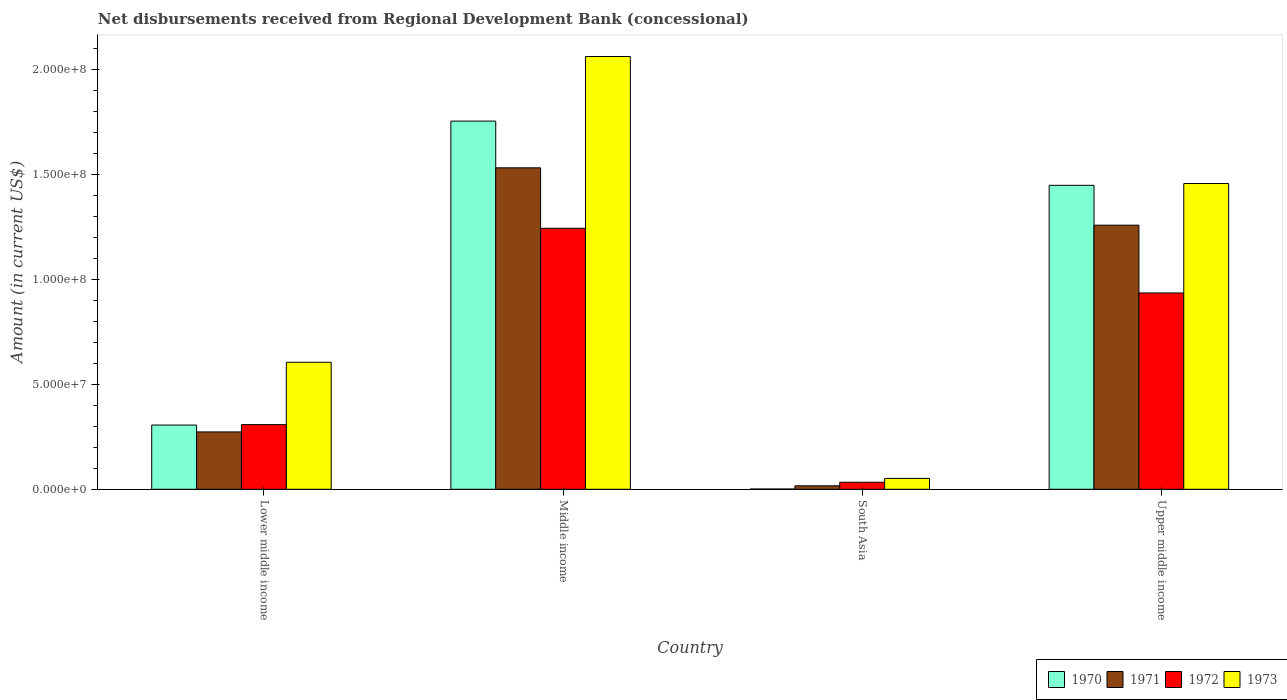How many different coloured bars are there?
Offer a terse response. 4. Are the number of bars per tick equal to the number of legend labels?
Offer a very short reply. Yes. Are the number of bars on each tick of the X-axis equal?
Offer a terse response. Yes. What is the label of the 1st group of bars from the left?
Give a very brief answer. Lower middle income. In how many cases, is the number of bars for a given country not equal to the number of legend labels?
Keep it short and to the point. 0. What is the amount of disbursements received from Regional Development Bank in 1973 in Middle income?
Ensure brevity in your answer.  2.06e+08. Across all countries, what is the maximum amount of disbursements received from Regional Development Bank in 1971?
Provide a succinct answer. 1.53e+08. Across all countries, what is the minimum amount of disbursements received from Regional Development Bank in 1973?
Provide a succinct answer. 5.18e+06. In which country was the amount of disbursements received from Regional Development Bank in 1971 maximum?
Give a very brief answer. Middle income. What is the total amount of disbursements received from Regional Development Bank in 1972 in the graph?
Offer a terse response. 2.52e+08. What is the difference between the amount of disbursements received from Regional Development Bank in 1973 in Lower middle income and that in South Asia?
Offer a very short reply. 5.54e+07. What is the difference between the amount of disbursements received from Regional Development Bank in 1970 in South Asia and the amount of disbursements received from Regional Development Bank in 1971 in Lower middle income?
Ensure brevity in your answer.  -2.72e+07. What is the average amount of disbursements received from Regional Development Bank in 1971 per country?
Offer a terse response. 7.70e+07. What is the difference between the amount of disbursements received from Regional Development Bank of/in 1971 and amount of disbursements received from Regional Development Bank of/in 1972 in Lower middle income?
Your response must be concise. -3.47e+06. In how many countries, is the amount of disbursements received from Regional Development Bank in 1970 greater than 120000000 US$?
Offer a very short reply. 2. What is the ratio of the amount of disbursements received from Regional Development Bank in 1973 in Lower middle income to that in South Asia?
Ensure brevity in your answer.  11.68. Is the amount of disbursements received from Regional Development Bank in 1971 in Lower middle income less than that in South Asia?
Ensure brevity in your answer.  No. Is the difference between the amount of disbursements received from Regional Development Bank in 1971 in Middle income and South Asia greater than the difference between the amount of disbursements received from Regional Development Bank in 1972 in Middle income and South Asia?
Provide a short and direct response. Yes. What is the difference between the highest and the second highest amount of disbursements received from Regional Development Bank in 1973?
Offer a very short reply. 6.06e+07. What is the difference between the highest and the lowest amount of disbursements received from Regional Development Bank in 1973?
Make the answer very short. 2.01e+08. Is it the case that in every country, the sum of the amount of disbursements received from Regional Development Bank in 1970 and amount of disbursements received from Regional Development Bank in 1973 is greater than the sum of amount of disbursements received from Regional Development Bank in 1971 and amount of disbursements received from Regional Development Bank in 1972?
Offer a terse response. No. What does the 4th bar from the left in Upper middle income represents?
Your response must be concise. 1973. What does the 2nd bar from the right in South Asia represents?
Your answer should be very brief. 1972. How many bars are there?
Your response must be concise. 16. Are all the bars in the graph horizontal?
Give a very brief answer. No. How many countries are there in the graph?
Provide a succinct answer. 4. What is the difference between two consecutive major ticks on the Y-axis?
Ensure brevity in your answer.  5.00e+07. Where does the legend appear in the graph?
Your response must be concise. Bottom right. How many legend labels are there?
Keep it short and to the point. 4. How are the legend labels stacked?
Provide a succinct answer. Horizontal. What is the title of the graph?
Provide a short and direct response. Net disbursements received from Regional Development Bank (concessional). Does "2014" appear as one of the legend labels in the graph?
Give a very brief answer. No. What is the label or title of the X-axis?
Offer a very short reply. Country. What is the Amount (in current US$) in 1970 in Lower middle income?
Make the answer very short. 3.06e+07. What is the Amount (in current US$) in 1971 in Lower middle income?
Provide a succinct answer. 2.74e+07. What is the Amount (in current US$) in 1972 in Lower middle income?
Give a very brief answer. 3.08e+07. What is the Amount (in current US$) in 1973 in Lower middle income?
Ensure brevity in your answer.  6.06e+07. What is the Amount (in current US$) in 1970 in Middle income?
Keep it short and to the point. 1.76e+08. What is the Amount (in current US$) of 1971 in Middle income?
Your answer should be compact. 1.53e+08. What is the Amount (in current US$) in 1972 in Middle income?
Make the answer very short. 1.24e+08. What is the Amount (in current US$) of 1973 in Middle income?
Provide a succinct answer. 2.06e+08. What is the Amount (in current US$) of 1970 in South Asia?
Make the answer very short. 1.09e+05. What is the Amount (in current US$) in 1971 in South Asia?
Your answer should be very brief. 1.65e+06. What is the Amount (in current US$) of 1972 in South Asia?
Provide a short and direct response. 3.35e+06. What is the Amount (in current US$) in 1973 in South Asia?
Provide a succinct answer. 5.18e+06. What is the Amount (in current US$) of 1970 in Upper middle income?
Ensure brevity in your answer.  1.45e+08. What is the Amount (in current US$) of 1971 in Upper middle income?
Your answer should be very brief. 1.26e+08. What is the Amount (in current US$) of 1972 in Upper middle income?
Offer a very short reply. 9.36e+07. What is the Amount (in current US$) in 1973 in Upper middle income?
Make the answer very short. 1.46e+08. Across all countries, what is the maximum Amount (in current US$) of 1970?
Your answer should be compact. 1.76e+08. Across all countries, what is the maximum Amount (in current US$) of 1971?
Your answer should be very brief. 1.53e+08. Across all countries, what is the maximum Amount (in current US$) in 1972?
Your answer should be very brief. 1.24e+08. Across all countries, what is the maximum Amount (in current US$) of 1973?
Give a very brief answer. 2.06e+08. Across all countries, what is the minimum Amount (in current US$) of 1970?
Your answer should be compact. 1.09e+05. Across all countries, what is the minimum Amount (in current US$) in 1971?
Ensure brevity in your answer.  1.65e+06. Across all countries, what is the minimum Amount (in current US$) in 1972?
Provide a short and direct response. 3.35e+06. Across all countries, what is the minimum Amount (in current US$) in 1973?
Your response must be concise. 5.18e+06. What is the total Amount (in current US$) of 1970 in the graph?
Provide a short and direct response. 3.51e+08. What is the total Amount (in current US$) of 1971 in the graph?
Your answer should be compact. 3.08e+08. What is the total Amount (in current US$) in 1972 in the graph?
Your response must be concise. 2.52e+08. What is the total Amount (in current US$) of 1973 in the graph?
Ensure brevity in your answer.  4.18e+08. What is the difference between the Amount (in current US$) of 1970 in Lower middle income and that in Middle income?
Provide a short and direct response. -1.45e+08. What is the difference between the Amount (in current US$) of 1971 in Lower middle income and that in Middle income?
Your answer should be very brief. -1.26e+08. What is the difference between the Amount (in current US$) in 1972 in Lower middle income and that in Middle income?
Offer a very short reply. -9.36e+07. What is the difference between the Amount (in current US$) in 1973 in Lower middle income and that in Middle income?
Your answer should be very brief. -1.46e+08. What is the difference between the Amount (in current US$) in 1970 in Lower middle income and that in South Asia?
Provide a succinct answer. 3.05e+07. What is the difference between the Amount (in current US$) of 1971 in Lower middle income and that in South Asia?
Give a very brief answer. 2.57e+07. What is the difference between the Amount (in current US$) of 1972 in Lower middle income and that in South Asia?
Offer a very short reply. 2.75e+07. What is the difference between the Amount (in current US$) in 1973 in Lower middle income and that in South Asia?
Provide a short and direct response. 5.54e+07. What is the difference between the Amount (in current US$) of 1970 in Lower middle income and that in Upper middle income?
Your answer should be very brief. -1.14e+08. What is the difference between the Amount (in current US$) in 1971 in Lower middle income and that in Upper middle income?
Offer a very short reply. -9.86e+07. What is the difference between the Amount (in current US$) of 1972 in Lower middle income and that in Upper middle income?
Provide a short and direct response. -6.28e+07. What is the difference between the Amount (in current US$) of 1973 in Lower middle income and that in Upper middle income?
Give a very brief answer. -8.52e+07. What is the difference between the Amount (in current US$) in 1970 in Middle income and that in South Asia?
Provide a short and direct response. 1.75e+08. What is the difference between the Amount (in current US$) of 1971 in Middle income and that in South Asia?
Keep it short and to the point. 1.52e+08. What is the difference between the Amount (in current US$) in 1972 in Middle income and that in South Asia?
Keep it short and to the point. 1.21e+08. What is the difference between the Amount (in current US$) of 1973 in Middle income and that in South Asia?
Ensure brevity in your answer.  2.01e+08. What is the difference between the Amount (in current US$) in 1970 in Middle income and that in Upper middle income?
Your answer should be compact. 3.06e+07. What is the difference between the Amount (in current US$) in 1971 in Middle income and that in Upper middle income?
Keep it short and to the point. 2.74e+07. What is the difference between the Amount (in current US$) in 1972 in Middle income and that in Upper middle income?
Make the answer very short. 3.08e+07. What is the difference between the Amount (in current US$) of 1973 in Middle income and that in Upper middle income?
Ensure brevity in your answer.  6.06e+07. What is the difference between the Amount (in current US$) of 1970 in South Asia and that in Upper middle income?
Your answer should be very brief. -1.45e+08. What is the difference between the Amount (in current US$) of 1971 in South Asia and that in Upper middle income?
Provide a succinct answer. -1.24e+08. What is the difference between the Amount (in current US$) in 1972 in South Asia and that in Upper middle income?
Your answer should be compact. -9.03e+07. What is the difference between the Amount (in current US$) of 1973 in South Asia and that in Upper middle income?
Make the answer very short. -1.41e+08. What is the difference between the Amount (in current US$) of 1970 in Lower middle income and the Amount (in current US$) of 1971 in Middle income?
Offer a terse response. -1.23e+08. What is the difference between the Amount (in current US$) in 1970 in Lower middle income and the Amount (in current US$) in 1972 in Middle income?
Your answer should be compact. -9.38e+07. What is the difference between the Amount (in current US$) of 1970 in Lower middle income and the Amount (in current US$) of 1973 in Middle income?
Keep it short and to the point. -1.76e+08. What is the difference between the Amount (in current US$) in 1971 in Lower middle income and the Amount (in current US$) in 1972 in Middle income?
Your response must be concise. -9.71e+07. What is the difference between the Amount (in current US$) in 1971 in Lower middle income and the Amount (in current US$) in 1973 in Middle income?
Give a very brief answer. -1.79e+08. What is the difference between the Amount (in current US$) in 1972 in Lower middle income and the Amount (in current US$) in 1973 in Middle income?
Ensure brevity in your answer.  -1.76e+08. What is the difference between the Amount (in current US$) of 1970 in Lower middle income and the Amount (in current US$) of 1971 in South Asia?
Give a very brief answer. 2.90e+07. What is the difference between the Amount (in current US$) of 1970 in Lower middle income and the Amount (in current US$) of 1972 in South Asia?
Offer a very short reply. 2.73e+07. What is the difference between the Amount (in current US$) in 1970 in Lower middle income and the Amount (in current US$) in 1973 in South Asia?
Offer a terse response. 2.54e+07. What is the difference between the Amount (in current US$) of 1971 in Lower middle income and the Amount (in current US$) of 1972 in South Asia?
Your response must be concise. 2.40e+07. What is the difference between the Amount (in current US$) of 1971 in Lower middle income and the Amount (in current US$) of 1973 in South Asia?
Keep it short and to the point. 2.22e+07. What is the difference between the Amount (in current US$) in 1972 in Lower middle income and the Amount (in current US$) in 1973 in South Asia?
Offer a very short reply. 2.56e+07. What is the difference between the Amount (in current US$) in 1970 in Lower middle income and the Amount (in current US$) in 1971 in Upper middle income?
Your answer should be very brief. -9.53e+07. What is the difference between the Amount (in current US$) in 1970 in Lower middle income and the Amount (in current US$) in 1972 in Upper middle income?
Provide a short and direct response. -6.30e+07. What is the difference between the Amount (in current US$) of 1970 in Lower middle income and the Amount (in current US$) of 1973 in Upper middle income?
Your answer should be very brief. -1.15e+08. What is the difference between the Amount (in current US$) in 1971 in Lower middle income and the Amount (in current US$) in 1972 in Upper middle income?
Offer a very short reply. -6.63e+07. What is the difference between the Amount (in current US$) in 1971 in Lower middle income and the Amount (in current US$) in 1973 in Upper middle income?
Provide a short and direct response. -1.18e+08. What is the difference between the Amount (in current US$) in 1972 in Lower middle income and the Amount (in current US$) in 1973 in Upper middle income?
Provide a short and direct response. -1.15e+08. What is the difference between the Amount (in current US$) in 1970 in Middle income and the Amount (in current US$) in 1971 in South Asia?
Ensure brevity in your answer.  1.74e+08. What is the difference between the Amount (in current US$) of 1970 in Middle income and the Amount (in current US$) of 1972 in South Asia?
Provide a succinct answer. 1.72e+08. What is the difference between the Amount (in current US$) of 1970 in Middle income and the Amount (in current US$) of 1973 in South Asia?
Offer a very short reply. 1.70e+08. What is the difference between the Amount (in current US$) in 1971 in Middle income and the Amount (in current US$) in 1972 in South Asia?
Your answer should be very brief. 1.50e+08. What is the difference between the Amount (in current US$) of 1971 in Middle income and the Amount (in current US$) of 1973 in South Asia?
Ensure brevity in your answer.  1.48e+08. What is the difference between the Amount (in current US$) in 1972 in Middle income and the Amount (in current US$) in 1973 in South Asia?
Offer a very short reply. 1.19e+08. What is the difference between the Amount (in current US$) of 1970 in Middle income and the Amount (in current US$) of 1971 in Upper middle income?
Offer a very short reply. 4.96e+07. What is the difference between the Amount (in current US$) in 1970 in Middle income and the Amount (in current US$) in 1972 in Upper middle income?
Provide a short and direct response. 8.19e+07. What is the difference between the Amount (in current US$) in 1970 in Middle income and the Amount (in current US$) in 1973 in Upper middle income?
Offer a very short reply. 2.98e+07. What is the difference between the Amount (in current US$) in 1971 in Middle income and the Amount (in current US$) in 1972 in Upper middle income?
Provide a short and direct response. 5.97e+07. What is the difference between the Amount (in current US$) of 1971 in Middle income and the Amount (in current US$) of 1973 in Upper middle income?
Offer a terse response. 7.49e+06. What is the difference between the Amount (in current US$) in 1972 in Middle income and the Amount (in current US$) in 1973 in Upper middle income?
Your answer should be compact. -2.14e+07. What is the difference between the Amount (in current US$) of 1970 in South Asia and the Amount (in current US$) of 1971 in Upper middle income?
Your response must be concise. -1.26e+08. What is the difference between the Amount (in current US$) in 1970 in South Asia and the Amount (in current US$) in 1972 in Upper middle income?
Offer a terse response. -9.35e+07. What is the difference between the Amount (in current US$) in 1970 in South Asia and the Amount (in current US$) in 1973 in Upper middle income?
Your response must be concise. -1.46e+08. What is the difference between the Amount (in current US$) of 1971 in South Asia and the Amount (in current US$) of 1972 in Upper middle income?
Give a very brief answer. -9.20e+07. What is the difference between the Amount (in current US$) of 1971 in South Asia and the Amount (in current US$) of 1973 in Upper middle income?
Keep it short and to the point. -1.44e+08. What is the difference between the Amount (in current US$) in 1972 in South Asia and the Amount (in current US$) in 1973 in Upper middle income?
Your response must be concise. -1.42e+08. What is the average Amount (in current US$) of 1970 per country?
Give a very brief answer. 8.78e+07. What is the average Amount (in current US$) in 1971 per country?
Your response must be concise. 7.70e+07. What is the average Amount (in current US$) in 1972 per country?
Provide a short and direct response. 6.31e+07. What is the average Amount (in current US$) of 1973 per country?
Provide a succinct answer. 1.04e+08. What is the difference between the Amount (in current US$) of 1970 and Amount (in current US$) of 1971 in Lower middle income?
Make the answer very short. 3.27e+06. What is the difference between the Amount (in current US$) in 1970 and Amount (in current US$) in 1972 in Lower middle income?
Ensure brevity in your answer.  -2.02e+05. What is the difference between the Amount (in current US$) in 1970 and Amount (in current US$) in 1973 in Lower middle income?
Provide a short and direct response. -2.99e+07. What is the difference between the Amount (in current US$) in 1971 and Amount (in current US$) in 1972 in Lower middle income?
Offer a terse response. -3.47e+06. What is the difference between the Amount (in current US$) of 1971 and Amount (in current US$) of 1973 in Lower middle income?
Your answer should be very brief. -3.32e+07. What is the difference between the Amount (in current US$) in 1972 and Amount (in current US$) in 1973 in Lower middle income?
Give a very brief answer. -2.97e+07. What is the difference between the Amount (in current US$) in 1970 and Amount (in current US$) in 1971 in Middle income?
Provide a succinct answer. 2.23e+07. What is the difference between the Amount (in current US$) in 1970 and Amount (in current US$) in 1972 in Middle income?
Give a very brief answer. 5.11e+07. What is the difference between the Amount (in current US$) in 1970 and Amount (in current US$) in 1973 in Middle income?
Ensure brevity in your answer.  -3.08e+07. What is the difference between the Amount (in current US$) in 1971 and Amount (in current US$) in 1972 in Middle income?
Offer a terse response. 2.88e+07. What is the difference between the Amount (in current US$) in 1971 and Amount (in current US$) in 1973 in Middle income?
Provide a succinct answer. -5.31e+07. What is the difference between the Amount (in current US$) of 1972 and Amount (in current US$) of 1973 in Middle income?
Offer a terse response. -8.19e+07. What is the difference between the Amount (in current US$) in 1970 and Amount (in current US$) in 1971 in South Asia?
Make the answer very short. -1.54e+06. What is the difference between the Amount (in current US$) in 1970 and Amount (in current US$) in 1972 in South Asia?
Ensure brevity in your answer.  -3.24e+06. What is the difference between the Amount (in current US$) in 1970 and Amount (in current US$) in 1973 in South Asia?
Your response must be concise. -5.08e+06. What is the difference between the Amount (in current US$) of 1971 and Amount (in current US$) of 1972 in South Asia?
Your response must be concise. -1.70e+06. What is the difference between the Amount (in current US$) of 1971 and Amount (in current US$) of 1973 in South Asia?
Provide a succinct answer. -3.53e+06. What is the difference between the Amount (in current US$) of 1972 and Amount (in current US$) of 1973 in South Asia?
Keep it short and to the point. -1.83e+06. What is the difference between the Amount (in current US$) in 1970 and Amount (in current US$) in 1971 in Upper middle income?
Keep it short and to the point. 1.90e+07. What is the difference between the Amount (in current US$) of 1970 and Amount (in current US$) of 1972 in Upper middle income?
Make the answer very short. 5.13e+07. What is the difference between the Amount (in current US$) in 1970 and Amount (in current US$) in 1973 in Upper middle income?
Your answer should be compact. -8.58e+05. What is the difference between the Amount (in current US$) of 1971 and Amount (in current US$) of 1972 in Upper middle income?
Keep it short and to the point. 3.23e+07. What is the difference between the Amount (in current US$) of 1971 and Amount (in current US$) of 1973 in Upper middle income?
Ensure brevity in your answer.  -1.99e+07. What is the difference between the Amount (in current US$) of 1972 and Amount (in current US$) of 1973 in Upper middle income?
Keep it short and to the point. -5.22e+07. What is the ratio of the Amount (in current US$) in 1970 in Lower middle income to that in Middle income?
Ensure brevity in your answer.  0.17. What is the ratio of the Amount (in current US$) in 1971 in Lower middle income to that in Middle income?
Provide a short and direct response. 0.18. What is the ratio of the Amount (in current US$) of 1972 in Lower middle income to that in Middle income?
Ensure brevity in your answer.  0.25. What is the ratio of the Amount (in current US$) of 1973 in Lower middle income to that in Middle income?
Offer a terse response. 0.29. What is the ratio of the Amount (in current US$) in 1970 in Lower middle income to that in South Asia?
Your response must be concise. 280.94. What is the ratio of the Amount (in current US$) in 1971 in Lower middle income to that in South Asia?
Your response must be concise. 16.58. What is the ratio of the Amount (in current US$) in 1972 in Lower middle income to that in South Asia?
Your answer should be very brief. 9.2. What is the ratio of the Amount (in current US$) in 1973 in Lower middle income to that in South Asia?
Ensure brevity in your answer.  11.68. What is the ratio of the Amount (in current US$) of 1970 in Lower middle income to that in Upper middle income?
Give a very brief answer. 0.21. What is the ratio of the Amount (in current US$) of 1971 in Lower middle income to that in Upper middle income?
Make the answer very short. 0.22. What is the ratio of the Amount (in current US$) of 1972 in Lower middle income to that in Upper middle income?
Keep it short and to the point. 0.33. What is the ratio of the Amount (in current US$) of 1973 in Lower middle income to that in Upper middle income?
Provide a succinct answer. 0.42. What is the ratio of the Amount (in current US$) in 1970 in Middle income to that in South Asia?
Ensure brevity in your answer.  1610.58. What is the ratio of the Amount (in current US$) in 1971 in Middle income to that in South Asia?
Your answer should be very brief. 92.89. What is the ratio of the Amount (in current US$) of 1972 in Middle income to that in South Asia?
Make the answer very short. 37.14. What is the ratio of the Amount (in current US$) of 1973 in Middle income to that in South Asia?
Provide a short and direct response. 39.8. What is the ratio of the Amount (in current US$) of 1970 in Middle income to that in Upper middle income?
Your answer should be compact. 1.21. What is the ratio of the Amount (in current US$) in 1971 in Middle income to that in Upper middle income?
Ensure brevity in your answer.  1.22. What is the ratio of the Amount (in current US$) of 1972 in Middle income to that in Upper middle income?
Provide a short and direct response. 1.33. What is the ratio of the Amount (in current US$) in 1973 in Middle income to that in Upper middle income?
Ensure brevity in your answer.  1.42. What is the ratio of the Amount (in current US$) of 1970 in South Asia to that in Upper middle income?
Make the answer very short. 0. What is the ratio of the Amount (in current US$) in 1971 in South Asia to that in Upper middle income?
Provide a short and direct response. 0.01. What is the ratio of the Amount (in current US$) in 1972 in South Asia to that in Upper middle income?
Your answer should be compact. 0.04. What is the ratio of the Amount (in current US$) in 1973 in South Asia to that in Upper middle income?
Make the answer very short. 0.04. What is the difference between the highest and the second highest Amount (in current US$) in 1970?
Your answer should be very brief. 3.06e+07. What is the difference between the highest and the second highest Amount (in current US$) in 1971?
Make the answer very short. 2.74e+07. What is the difference between the highest and the second highest Amount (in current US$) of 1972?
Your response must be concise. 3.08e+07. What is the difference between the highest and the second highest Amount (in current US$) in 1973?
Provide a short and direct response. 6.06e+07. What is the difference between the highest and the lowest Amount (in current US$) in 1970?
Ensure brevity in your answer.  1.75e+08. What is the difference between the highest and the lowest Amount (in current US$) of 1971?
Provide a succinct answer. 1.52e+08. What is the difference between the highest and the lowest Amount (in current US$) of 1972?
Keep it short and to the point. 1.21e+08. What is the difference between the highest and the lowest Amount (in current US$) in 1973?
Offer a very short reply. 2.01e+08. 